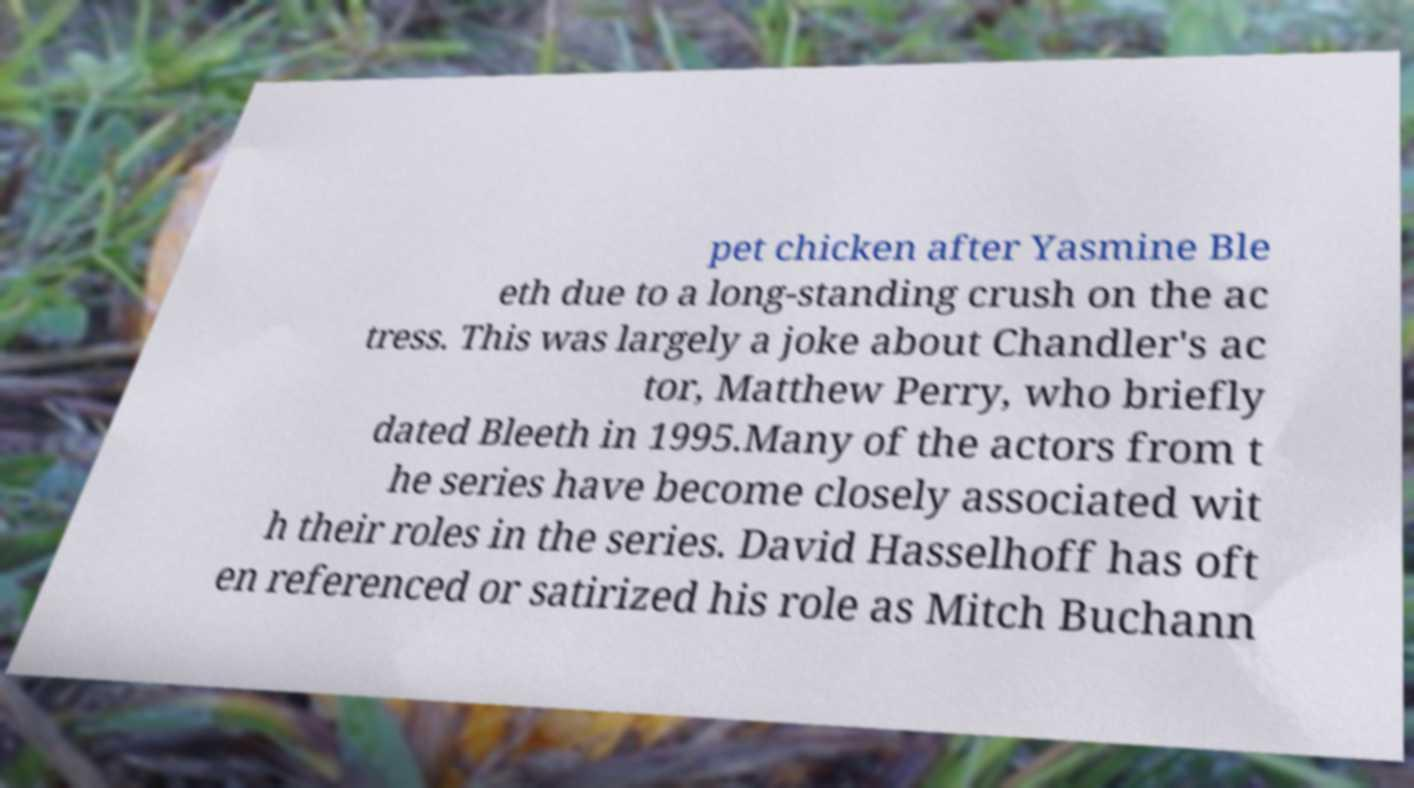I need the written content from this picture converted into text. Can you do that? pet chicken after Yasmine Ble eth due to a long-standing crush on the ac tress. This was largely a joke about Chandler's ac tor, Matthew Perry, who briefly dated Bleeth in 1995.Many of the actors from t he series have become closely associated wit h their roles in the series. David Hasselhoff has oft en referenced or satirized his role as Mitch Buchann 